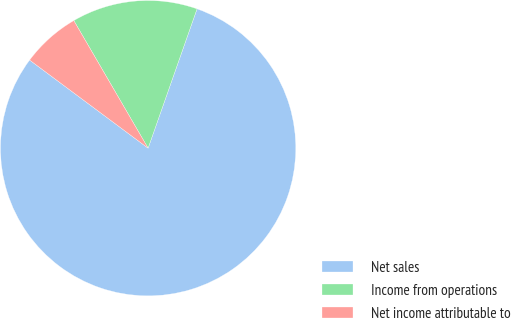Convert chart. <chart><loc_0><loc_0><loc_500><loc_500><pie_chart><fcel>Net sales<fcel>Income from operations<fcel>Net income attributable to<nl><fcel>79.8%<fcel>13.77%<fcel>6.43%<nl></chart> 